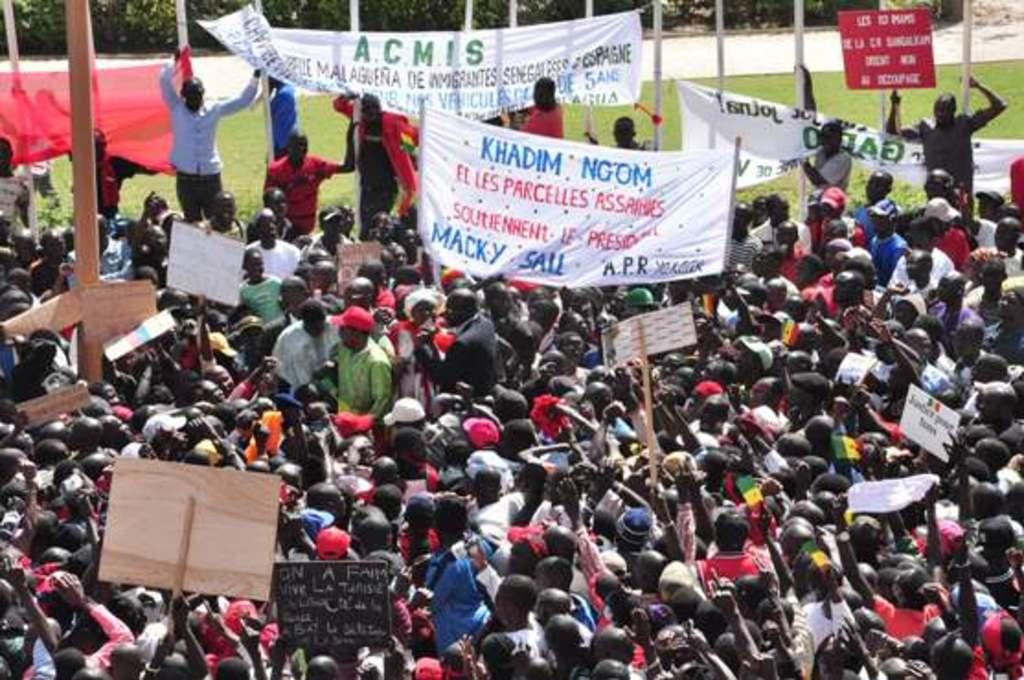How many people are in the image? There are people in the image, but the exact number is not specified. What are some of the people holding in the image? Some of the people are holding placards in the image. What can be seen on the banners in the image? There are banners with text in the image. What type of structures are present in the image? There are poles in the image. What type of vegetation is visible in the image? There are plants and grass visible in the image. What type of crook can be seen stealing a jar in the image? There is no crook or jar present in the image. What is the name of the son who is playing with the plants in the image? There is no child or specific person mentioned in the image, so it is not possible to determine the name of a son. 